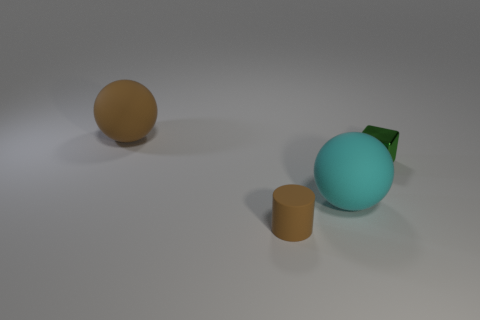There is a large object that is the same color as the small matte object; what shape is it?
Provide a short and direct response. Sphere. There is a cylinder; does it have the same color as the rubber ball behind the small green block?
Offer a terse response. Yes. There is a sphere that is the same color as the small matte cylinder; what is its size?
Offer a very short reply. Large. Is there a object of the same color as the tiny matte cylinder?
Your response must be concise. Yes. What material is the large object that is the same color as the tiny matte cylinder?
Provide a succinct answer. Rubber. There is a rubber thing behind the big cyan thing; is it the same color as the tiny thing on the left side of the metallic cube?
Provide a short and direct response. Yes. How many other objects are there of the same color as the tiny block?
Provide a short and direct response. 0. What number of brown things are small matte cylinders or balls?
Your response must be concise. 2. The green metallic block is what size?
Give a very brief answer. Small. How many rubber things are big brown spheres or large cyan spheres?
Your answer should be compact. 2. 